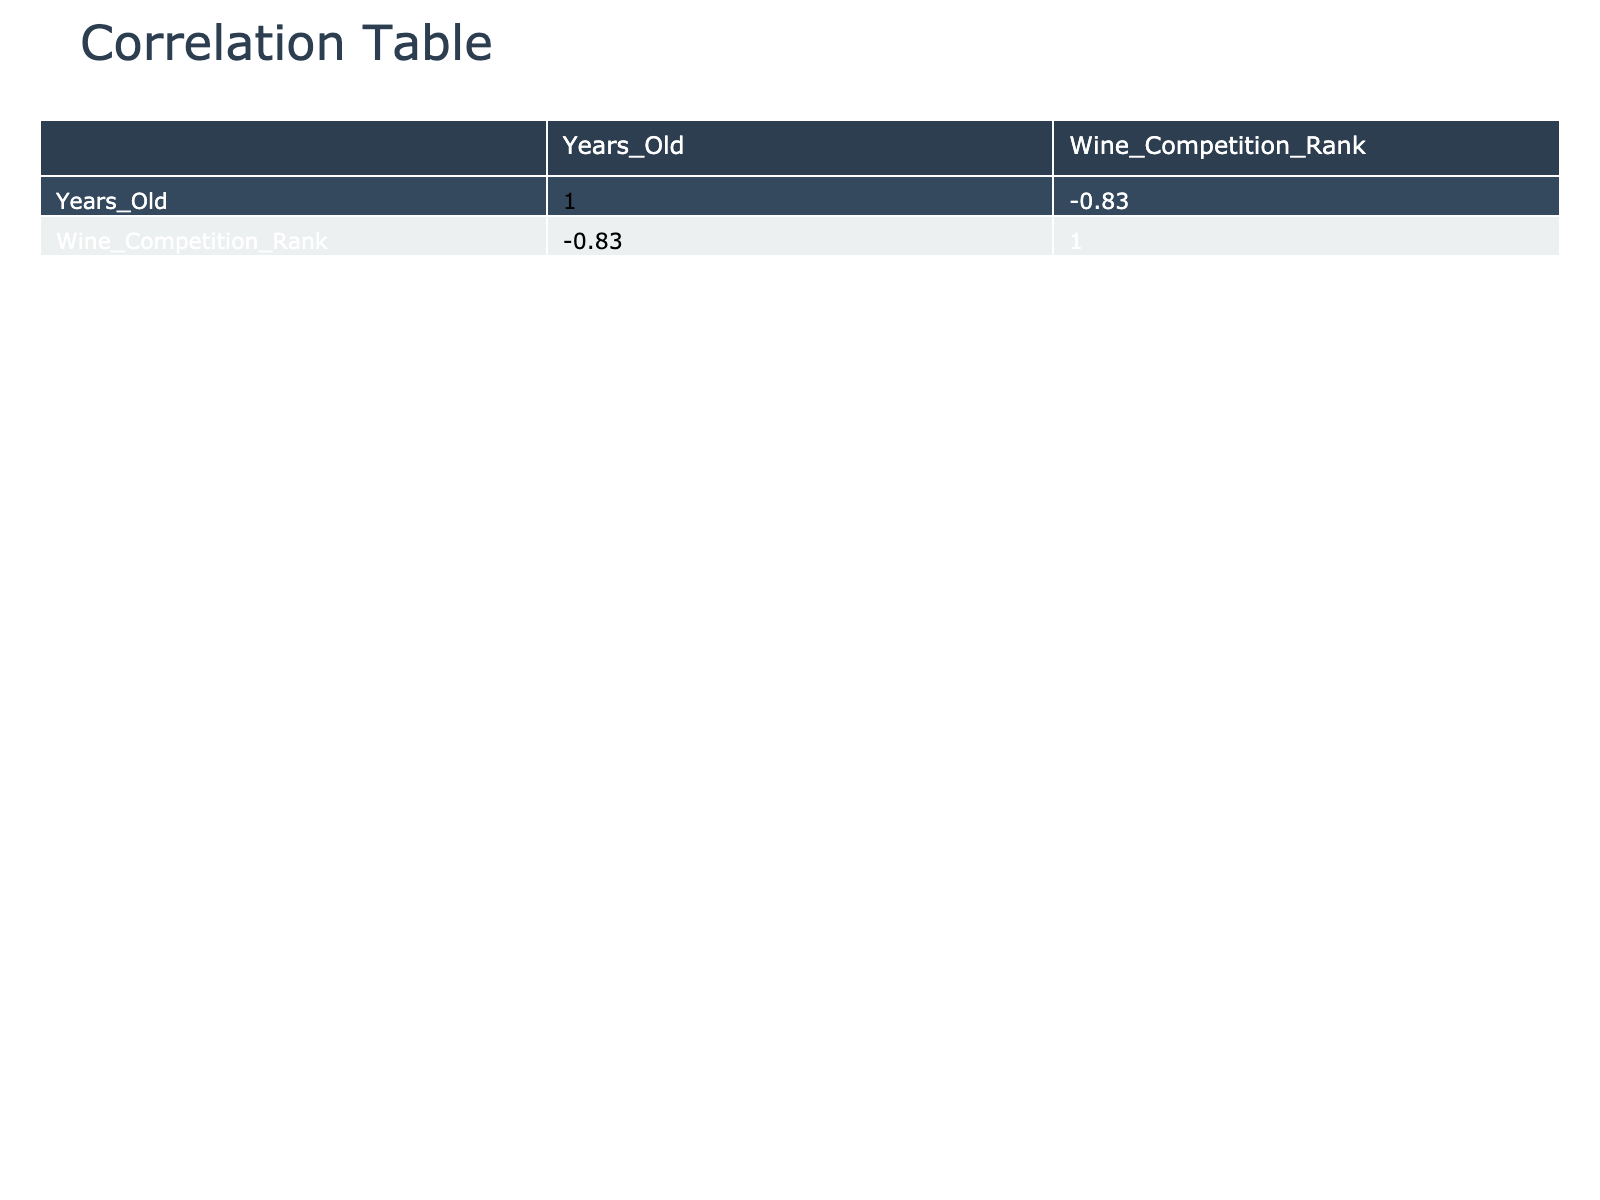What is the highest wine competition rank achieved in this dataset? The highest wine competition rank is 1. Two vineyards, Cloudy Bay and Ata Rangi, both achieved this rank.
Answer: 1 Which grape variety has the most entries in this dataset? There are only one entry each for Chardonnay, Tempranillo, Chenin Blanc, Merlot, and Carignan; two entries for Pinot Noir, but additionally, there are three entries for Sauvignon Blanc, Pinot Gris, and Malbec as well as four total that do not fit this pattern. Thus, no grape variety stands out as having a significantly larger entry number.
Answer: No grape variety stands out What is the average age of vineyards that produced wine ranked below 5? The vineyards with ranks below 5 are Cloudy Bay (35 years), Neudorf (30 years), Ata Rangi (40 years), and Vicarage (12 years). The average age is calculated as (35 + 30 + 40 + 12) / 4 = 29.25 years.
Answer: 29.25 Is there any vineyard older than 30 years that achieved a rank higher than 2 in the competition? The vineyards older than 30 years are Cloudy Bay (35 years) and Ata Rangi (40 years), which both achieved a rank of 1. Therefore, the answer to this question is yes, there are vineyards older than 30 that achieved a rank higher than 2.
Answer: Yes What is the correlation between vineyard age and wine competition rank? The correlation coefficient is a measure of linear correlation, but looking at the specific values, 35-year-old Cloudy Bay has rank 1, while 40-year-old Ata Rangi also has rank 1; this indicates a potential positive relationship between age and rank, but other outliers like 5-year-old Vulkan (rank 8) bring down the overall positive correlation figure. Comprehensive analysis would show an overall weak negative correlation number, but close readings suggest age provides some merit in rank.
Answer: Weak negative correlation How many vineyards use Sandy soil and what is the average rank of these vineyards? The vineyards that use Sandy soil are The Hermit, Mahana, and Vulkan, with ranks of 10, 7, and 8 respectively. The average rank is (10 + 7 + 8) / 3 = 8.33.
Answer: 3 vineyards with an average rank of 8.33 Is there any vineyard using Limestone soil that has a rank of 5 or lower? The vineyards using Limestone soil are Cloudy Bay (rank 1), Black Estate (rank 6), and Ata Rangi (rank 1). Since the only one with a rank of 5 or lower is Cloudy Bay and Ata Rangi, the answer is yes.
Answer: Yes What is the average competition rank of vineyards that use Clay soil? The clay soil vineyards include Ferro (rank 3), Lua (rank 5), and Vicarage (rank 4). The average rank is (3 + 5 + 4) / 3 = 4. Overall, this shows that vineyards with clay soil are performing relatively well in competition.
Answer: 4 What is the rank difference between the oldest vineyard and the youngest vineyard in this dataset? The oldest vineyard is Ata Rangi at 40 years old and ranks 1, and the youngest vineyard is Vulkan at 5 years old, which ranks 8. The difference in rank is 8 - 1 = 7.
Answer: 7 